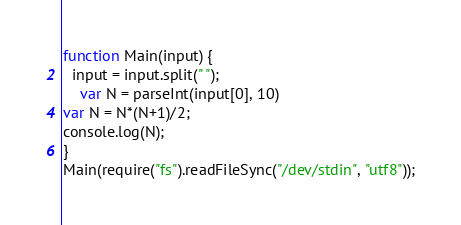Convert code to text. <code><loc_0><loc_0><loc_500><loc_500><_JavaScript_>function Main(input) {
  input = input.split(" ");
	var N = parseInt(input[0], 10)
var N = N*(N+1)/2;
console.log(N);
}
Main(require("fs").readFileSync("/dev/stdin", "utf8"));</code> 